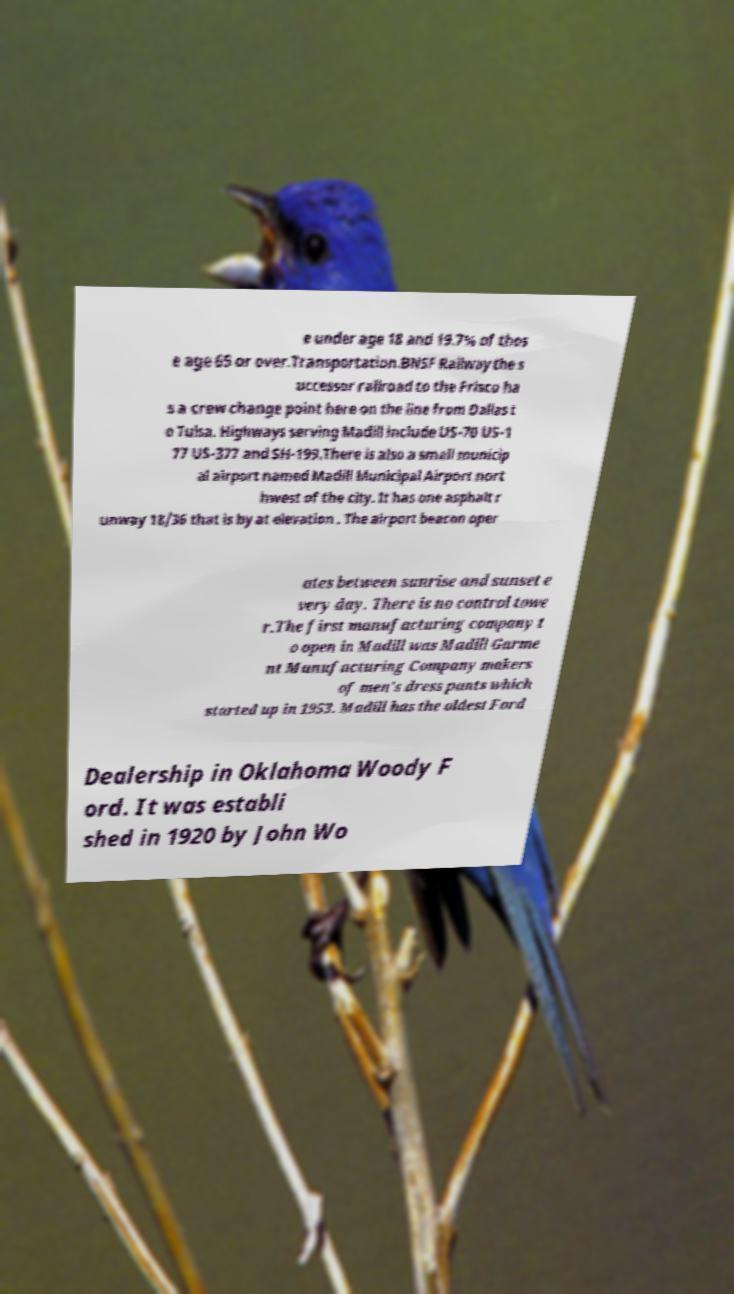Could you extract and type out the text from this image? e under age 18 and 19.7% of thos e age 65 or over.Transportation.BNSF Railway the s uccessor railroad to the Frisco ha s a crew change point here on the line from Dallas t o Tulsa. Highways serving Madill include US-70 US-1 77 US-377 and SH-199.There is also a small municip al airport named Madill Municipal Airport nort hwest of the city. It has one asphalt r unway 18/36 that is by at elevation . The airport beacon oper ates between sunrise and sunset e very day. There is no control towe r.The first manufacturing company t o open in Madill was Madill Garme nt Manufacturing Company makers of men's dress pants which started up in 1953. Madill has the oldest Ford Dealership in Oklahoma Woody F ord. It was establi shed in 1920 by John Wo 